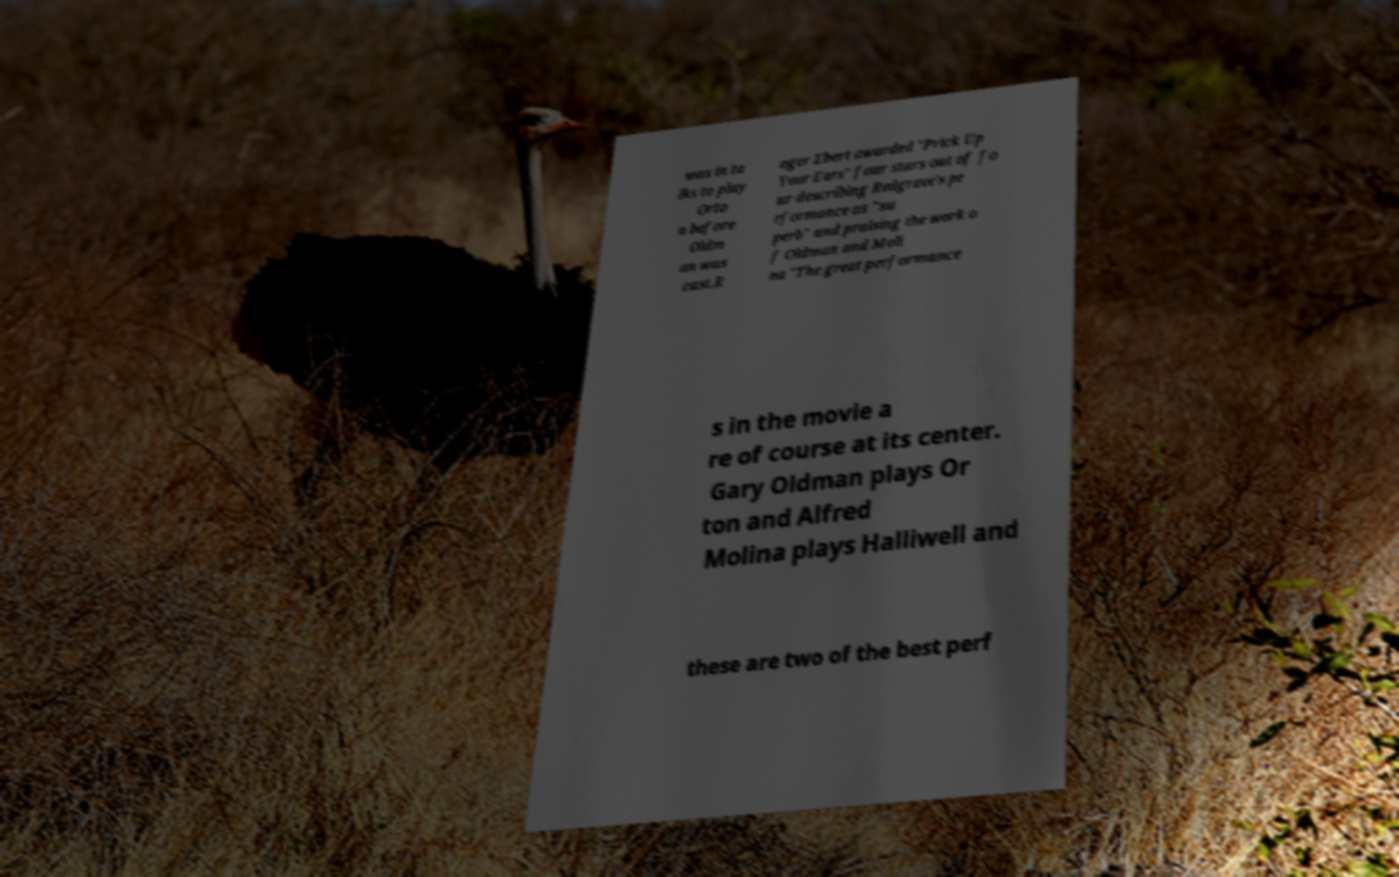Can you read and provide the text displayed in the image?This photo seems to have some interesting text. Can you extract and type it out for me? was in ta lks to play Orto n before Oldm an was cast.R oger Ebert awarded "Prick Up Your Ears" four stars out of fo ur describing Redgrave's pe rformance as "su perb" and praising the work o f Oldman and Moli na "The great performance s in the movie a re of course at its center. Gary Oldman plays Or ton and Alfred Molina plays Halliwell and these are two of the best perf 